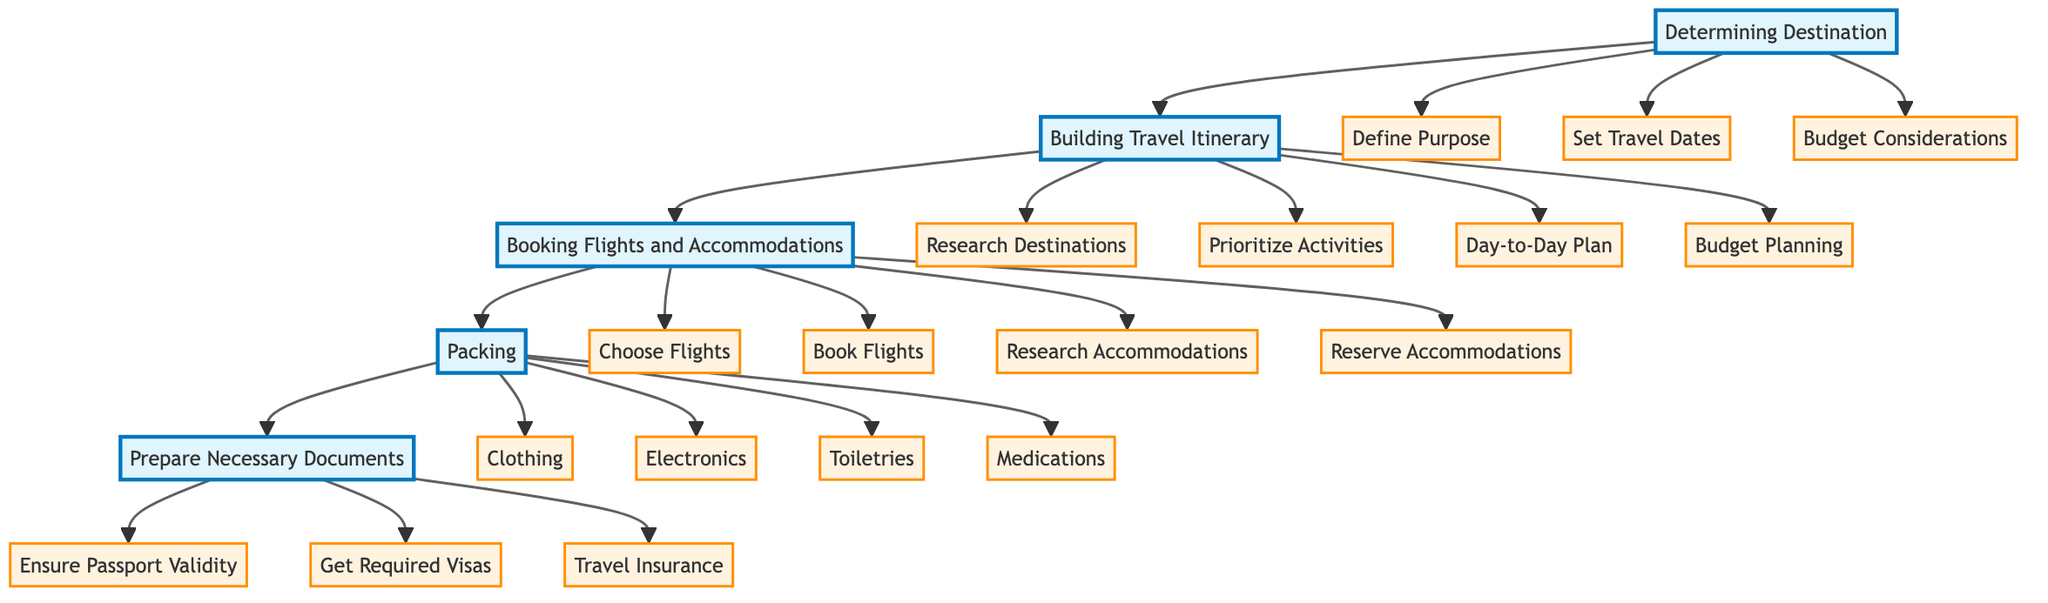What is the first step in the flowchart? The first step in the flowchart is "Determining Destination," as it is the top node that initiates the process.
Answer: Determining Destination How many main sections are in the flowchart? The flowchart has four main sections: Determining Destination, Building Travel Itinerary, Booking Flights and Accommodations, and Packing, followed by the final step, Prepare Necessary Documents.
Answer: Four What comes after "Building Travel Itinerary"? After "Building Travel Itinerary," the next step is "Booking Flights and Accommodations," indicating a sequential flow in the process.
Answer: Booking Flights and Accommodations What is the purpose of the node "Budget Considerations"? The node "Budget Considerations" serves to establish a travel budget that includes all necessary expenses, ensuring financial planning before proceeding.
Answer: Establish a travel budget Which step involves researching different lodging options? The step that involves researching different lodging options is "Research Accommodations," found within the "Booking Flights and Accommodations" section.
Answer: Research Accommodations How many tasks are there under "Packing"? There are four tasks under "Packing": Clothing, Electronics, Toiletries, and Medications, contributing to the packing preparation process.
Answer: Four Which step should be completed before "Ensure Passport Validity"? The step that should be completed before "Ensure Passport Validity" is "Prepare Necessary Documents," as it encompasses the actions needed to finalize document preparations.
Answer: Prepare Necessary Documents What is the final step in the travel preparation process? The final step in the travel preparation process is "Prepare Necessary Documents," which encompasses ensuring all necessary travel documents are in order.
Answer: Prepare Necessary Documents What section follows the first node in the flowchart? The section that follows the first node, "Determining Destination," is "Building Travel Itinerary," representing the next phase of travel planning.
Answer: Building Travel Itinerary 